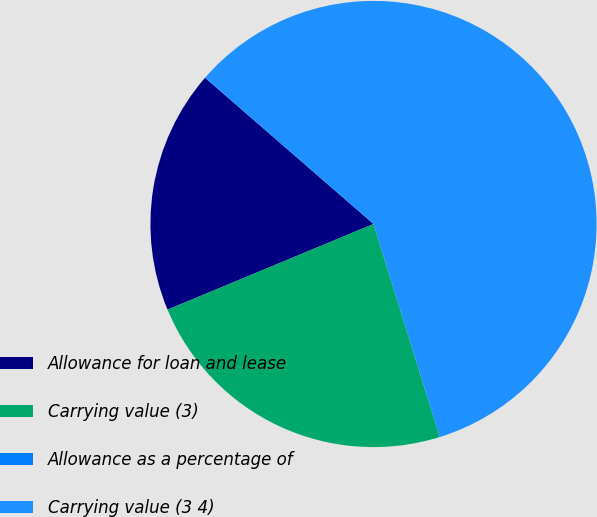Convert chart to OTSL. <chart><loc_0><loc_0><loc_500><loc_500><pie_chart><fcel>Allowance for loan and lease<fcel>Carrying value (3)<fcel>Allowance as a percentage of<fcel>Carrying value (3 4)<nl><fcel>17.65%<fcel>23.53%<fcel>0.0%<fcel>58.82%<nl></chart> 